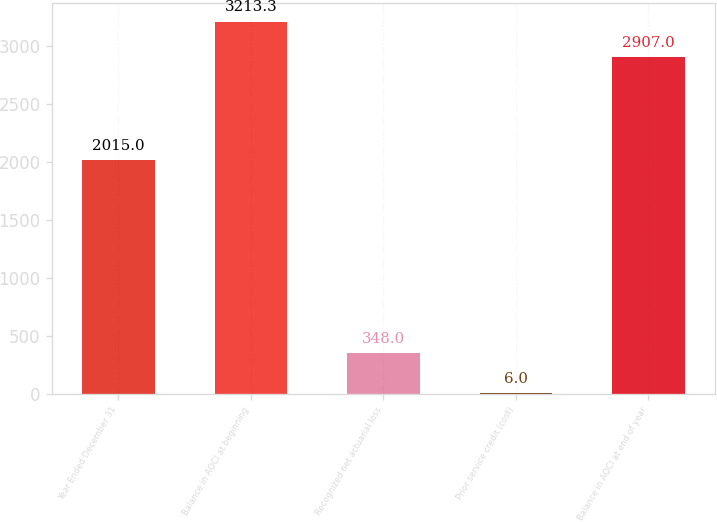Convert chart. <chart><loc_0><loc_0><loc_500><loc_500><bar_chart><fcel>Year Ended December 31<fcel>Balance in AOCI at beginning<fcel>Recognized net actuarial loss<fcel>Prior service credit (cost)<fcel>Balance in AOCI at end of year<nl><fcel>2015<fcel>3213.3<fcel>348<fcel>6<fcel>2907<nl></chart> 